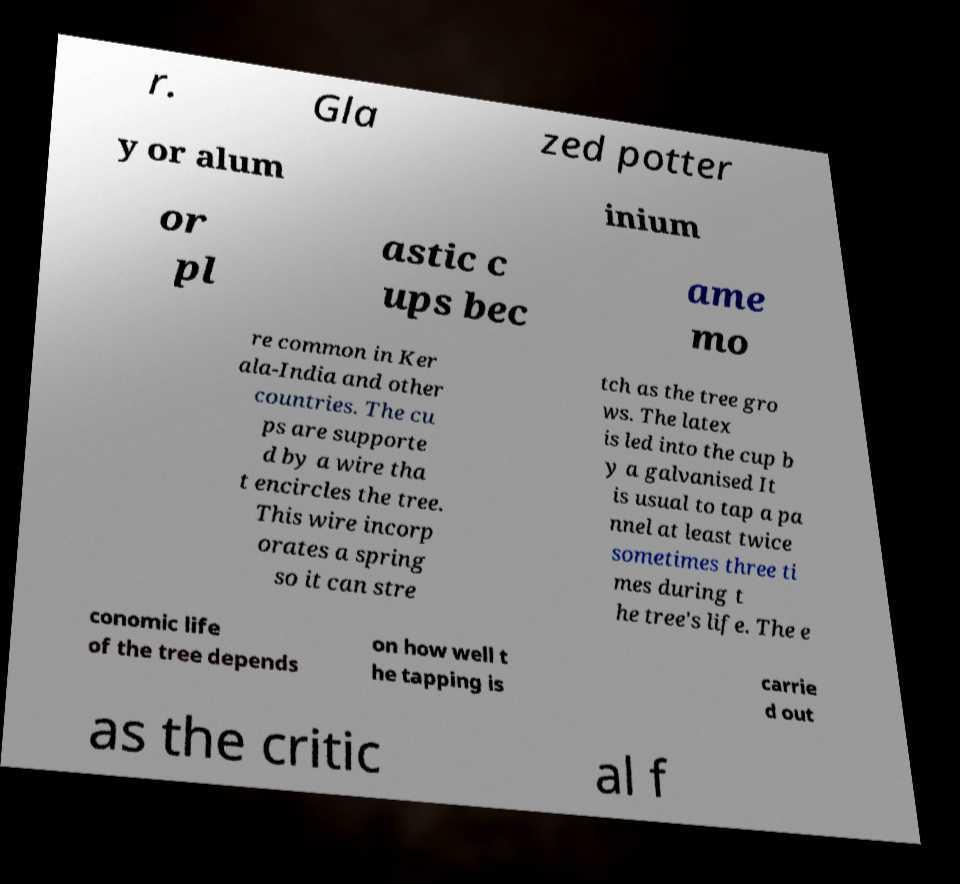Please identify and transcribe the text found in this image. r. Gla zed potter y or alum inium or pl astic c ups bec ame mo re common in Ker ala-India and other countries. The cu ps are supporte d by a wire tha t encircles the tree. This wire incorp orates a spring so it can stre tch as the tree gro ws. The latex is led into the cup b y a galvanised It is usual to tap a pa nnel at least twice sometimes three ti mes during t he tree's life. The e conomic life of the tree depends on how well t he tapping is carrie d out as the critic al f 